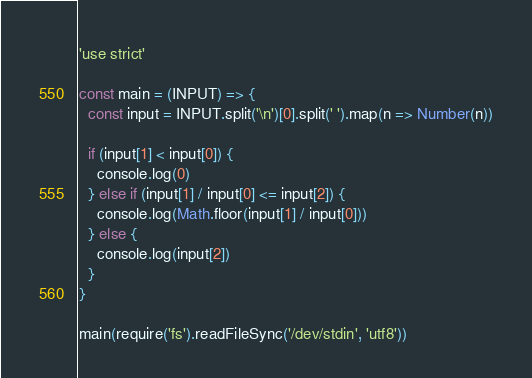Convert code to text. <code><loc_0><loc_0><loc_500><loc_500><_JavaScript_>'use strict'

const main = (INPUT) => {
  const input = INPUT.split('\n')[0].split(' ').map(n => Number(n))

  if (input[1] < input[0]) {
    console.log(0)
  } else if (input[1] / input[0] <= input[2]) {
    console.log(Math.floor(input[1] / input[0]))
  } else {
    console.log(input[2])
  }
}

main(require('fs').readFileSync('/dev/stdin', 'utf8'))
</code> 